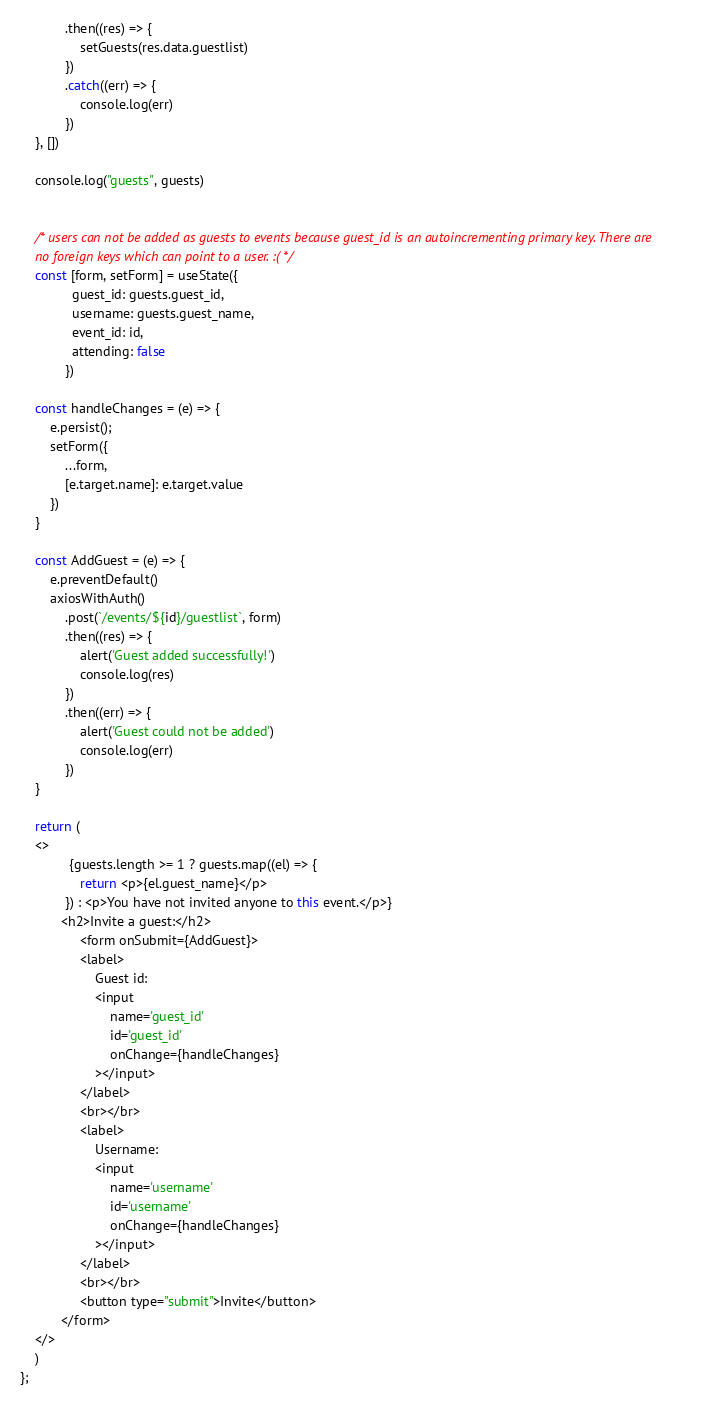Convert code to text. <code><loc_0><loc_0><loc_500><loc_500><_JavaScript_>            .then((res) => {
                setGuests(res.data.guestlist)
            })
            .catch((err) => {
                console.log(err)
            })
    }, [])

    console.log("guests", guests)


    /* users can not be added as guests to events because guest_id is an autoincrementing primary key. There are
    no foreign keys which can point to a user. :( */
    const [form, setForm] = useState({
              guest_id: guests.guest_id,
              username: guests.guest_name,
              event_id: id,
              attending: false
            })

    const handleChanges = (e) => {
        e.persist();
        setForm({
            ...form,
            [e.target.name]: e.target.value
        })
    }

    const AddGuest = (e) => {
        e.preventDefault()
        axiosWithAuth()
            .post(`/events/${id}/guestlist`, form)
            .then((res) => {
                alert('Guest added successfully!')
                console.log(res)
            })
            .then((err) => {
                alert('Guest could not be added')
                console.log(err)
            })
    }

    return (
    <>
             {guests.length >= 1 ? guests.map((el) => {
                return <p>{el.guest_name}</p>
            }) : <p>You have not invited anyone to this event.</p>}
           <h2>Invite a guest:</h2>
                <form onSubmit={AddGuest}>
                <label>
                    Guest id:
                    <input
                        name='guest_id'
                        id='guest_id'
                        onChange={handleChanges}
                    ></input>
                </label>
                <br></br>
                <label>
                    Username:
                    <input
                        name='username'
                        id='username'
                        onChange={handleChanges}
                    ></input>
                </label>
                <br></br>
                <button type="submit">Invite</button>
           </form>
    </>
    )
};</code> 